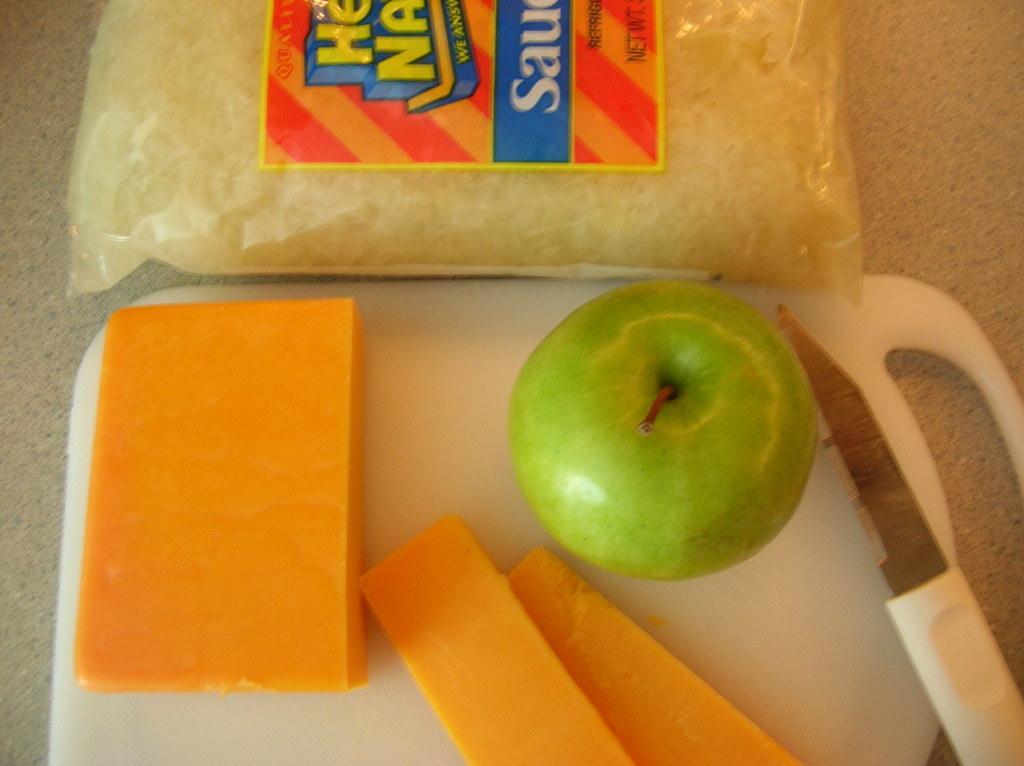Can you describe this image briefly? In this image I see the white color board on which there is a green apple and I see orange color things over here and I see a knife over here and I see the cover on which there is a sticker and I see words written on it. 